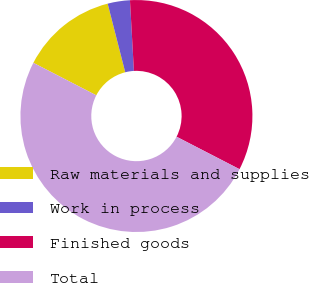<chart> <loc_0><loc_0><loc_500><loc_500><pie_chart><fcel>Raw materials and supplies<fcel>Work in process<fcel>Finished goods<fcel>Total<nl><fcel>13.43%<fcel>3.1%<fcel>33.47%<fcel>50.0%<nl></chart> 